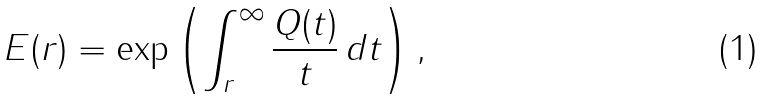<formula> <loc_0><loc_0><loc_500><loc_500>E ( r ) = \exp \left ( \int _ { r } ^ { \infty } \frac { Q ( t ) } { t } \, d t \right ) ,</formula> 